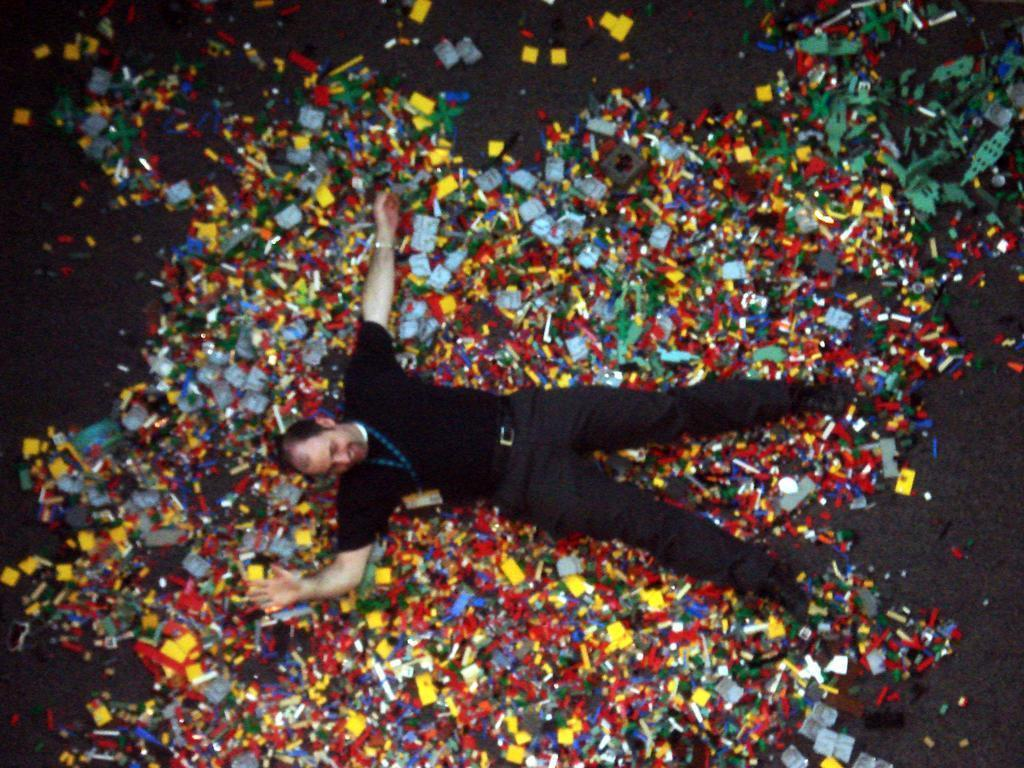What is on the floor in the image? There are cut pieces of decorative items on the floor. What is the person in the image doing? A person is laying on the decorative items. What color is the dress the person is wearing? The person is wearing a black color dress. What type of turkey is visible in the image? There is no turkey present in the image. How does the person's anger affect the decorative items in the image? The person's anger is not mentioned in the image, and there is no indication that the decorative items are affected by any emotion. 